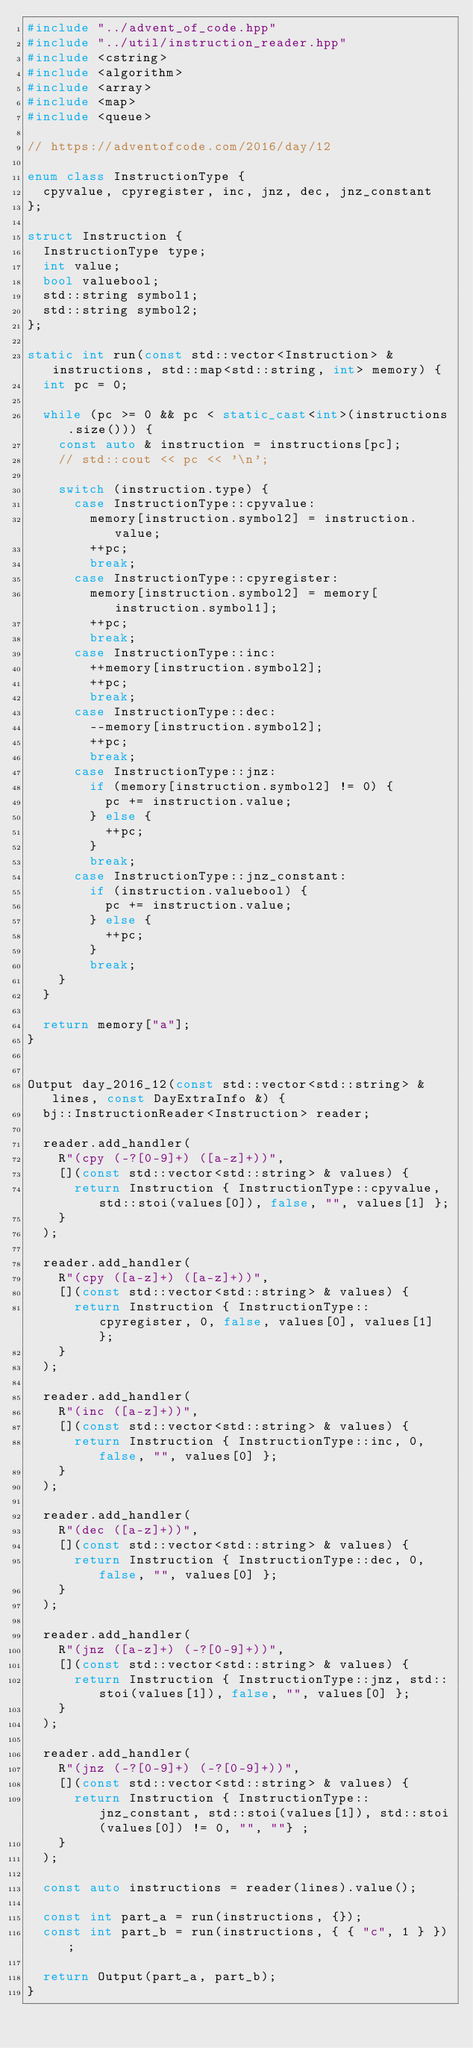Convert code to text. <code><loc_0><loc_0><loc_500><loc_500><_C++_>#include "../advent_of_code.hpp"
#include "../util/instruction_reader.hpp"
#include <cstring>
#include <algorithm>
#include <array>
#include <map>
#include <queue>

// https://adventofcode.com/2016/day/12

enum class InstructionType {
  cpyvalue, cpyregister, inc, jnz, dec, jnz_constant
};

struct Instruction {
  InstructionType type;
  int value;
  bool valuebool;
  std::string symbol1;
  std::string symbol2;
};

static int run(const std::vector<Instruction> & instructions, std::map<std::string, int> memory) {
  int pc = 0;
  
  while (pc >= 0 && pc < static_cast<int>(instructions.size())) {
    const auto & instruction = instructions[pc];
    // std::cout << pc << '\n';

    switch (instruction.type) {
      case InstructionType::cpyvalue:
        memory[instruction.symbol2] = instruction.value;
        ++pc;
        break;
      case InstructionType::cpyregister:
        memory[instruction.symbol2] = memory[instruction.symbol1];
        ++pc;
        break;
      case InstructionType::inc:
        ++memory[instruction.symbol2];
        ++pc;
        break;
      case InstructionType::dec:
        --memory[instruction.symbol2];
        ++pc;
        break;
      case InstructionType::jnz:
        if (memory[instruction.symbol2] != 0) {
          pc += instruction.value;
        } else {
          ++pc;
        }
        break;
      case InstructionType::jnz_constant:
        if (instruction.valuebool) {
          pc += instruction.value;
        } else {
          ++pc;
        }
        break;
    }
  }

  return memory["a"];
}


Output day_2016_12(const std::vector<std::string> & lines, const DayExtraInfo &) {
  bj::InstructionReader<Instruction> reader;

  reader.add_handler(
    R"(cpy (-?[0-9]+) ([a-z]+))",
    [](const std::vector<std::string> & values) {
      return Instruction { InstructionType::cpyvalue, std::stoi(values[0]), false, "", values[1] };
    }
  );

  reader.add_handler(
    R"(cpy ([a-z]+) ([a-z]+))",
    [](const std::vector<std::string> & values) {
      return Instruction { InstructionType::cpyregister, 0, false, values[0], values[1] };
    }
  );

  reader.add_handler(
    R"(inc ([a-z]+))",
    [](const std::vector<std::string> & values) {
      return Instruction { InstructionType::inc, 0, false, "", values[0] };
    }
  );

  reader.add_handler(
    R"(dec ([a-z]+))",
    [](const std::vector<std::string> & values) {
      return Instruction { InstructionType::dec, 0, false, "", values[0] };
    }
  );

  reader.add_handler(
    R"(jnz ([a-z]+) (-?[0-9]+))",
    [](const std::vector<std::string> & values) {
      return Instruction { InstructionType::jnz, std::stoi(values[1]), false, "", values[0] };
    }
  );

  reader.add_handler(
    R"(jnz (-?[0-9]+) (-?[0-9]+))",
    [](const std::vector<std::string> & values) {
      return Instruction { InstructionType::jnz_constant, std::stoi(values[1]), std::stoi(values[0]) != 0, "", ""} ;
    }
  );

  const auto instructions = reader(lines).value();

  const int part_a = run(instructions, {});
  const int part_b = run(instructions, { { "c", 1 } });

  return Output(part_a, part_b);
}
</code> 